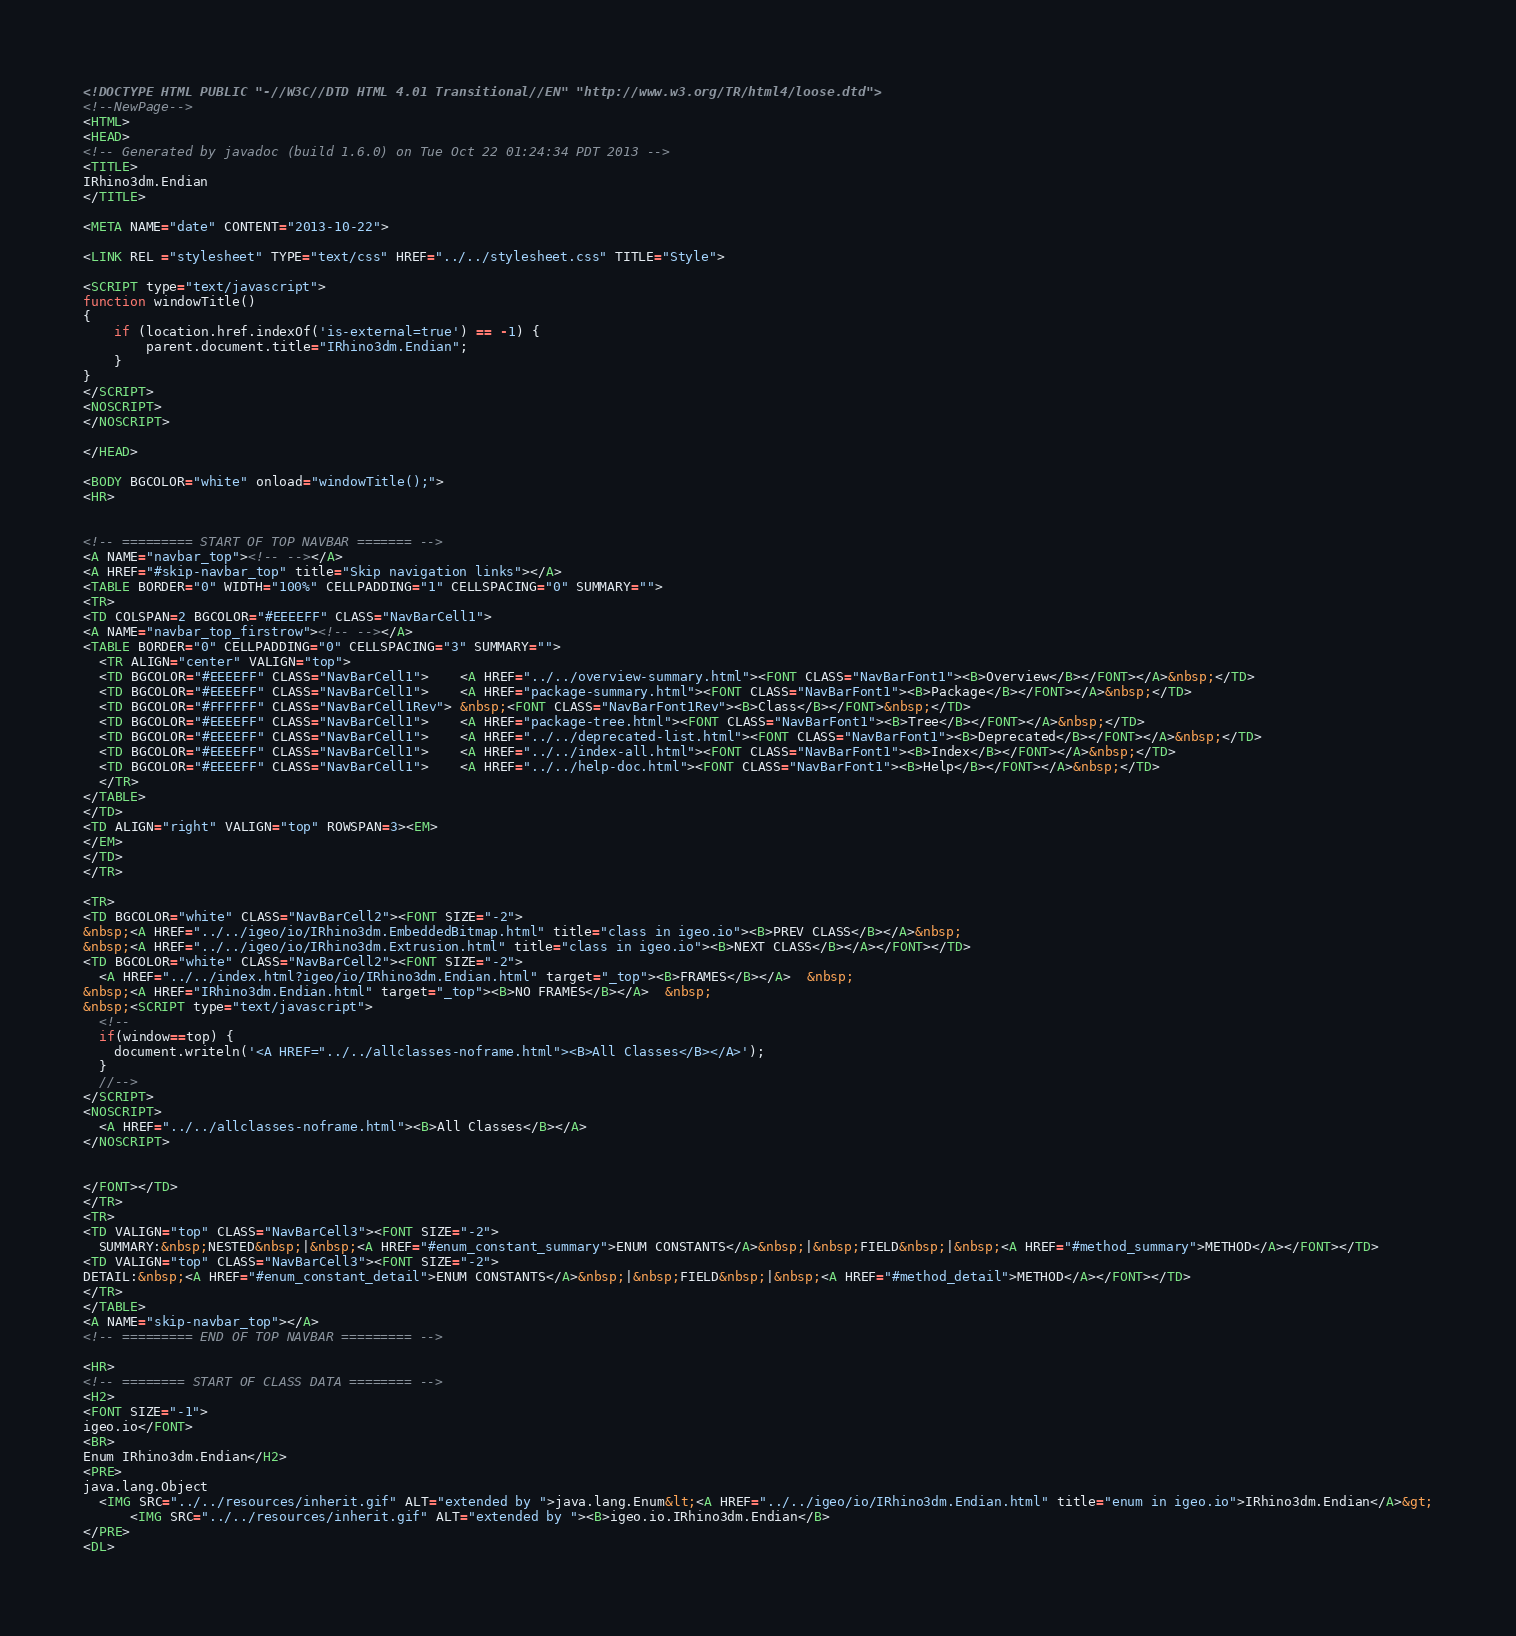<code> <loc_0><loc_0><loc_500><loc_500><_HTML_><!DOCTYPE HTML PUBLIC "-//W3C//DTD HTML 4.01 Transitional//EN" "http://www.w3.org/TR/html4/loose.dtd">
<!--NewPage-->
<HTML>
<HEAD>
<!-- Generated by javadoc (build 1.6.0) on Tue Oct 22 01:24:34 PDT 2013 -->
<TITLE>
IRhino3dm.Endian
</TITLE>

<META NAME="date" CONTENT="2013-10-22">

<LINK REL ="stylesheet" TYPE="text/css" HREF="../../stylesheet.css" TITLE="Style">

<SCRIPT type="text/javascript">
function windowTitle()
{
    if (location.href.indexOf('is-external=true') == -1) {
        parent.document.title="IRhino3dm.Endian";
    }
}
</SCRIPT>
<NOSCRIPT>
</NOSCRIPT>

</HEAD>

<BODY BGCOLOR="white" onload="windowTitle();">
<HR>


<!-- ========= START OF TOP NAVBAR ======= -->
<A NAME="navbar_top"><!-- --></A>
<A HREF="#skip-navbar_top" title="Skip navigation links"></A>
<TABLE BORDER="0" WIDTH="100%" CELLPADDING="1" CELLSPACING="0" SUMMARY="">
<TR>
<TD COLSPAN=2 BGCOLOR="#EEEEFF" CLASS="NavBarCell1">
<A NAME="navbar_top_firstrow"><!-- --></A>
<TABLE BORDER="0" CELLPADDING="0" CELLSPACING="3" SUMMARY="">
  <TR ALIGN="center" VALIGN="top">
  <TD BGCOLOR="#EEEEFF" CLASS="NavBarCell1">    <A HREF="../../overview-summary.html"><FONT CLASS="NavBarFont1"><B>Overview</B></FONT></A>&nbsp;</TD>
  <TD BGCOLOR="#EEEEFF" CLASS="NavBarCell1">    <A HREF="package-summary.html"><FONT CLASS="NavBarFont1"><B>Package</B></FONT></A>&nbsp;</TD>
  <TD BGCOLOR="#FFFFFF" CLASS="NavBarCell1Rev"> &nbsp;<FONT CLASS="NavBarFont1Rev"><B>Class</B></FONT>&nbsp;</TD>
  <TD BGCOLOR="#EEEEFF" CLASS="NavBarCell1">    <A HREF="package-tree.html"><FONT CLASS="NavBarFont1"><B>Tree</B></FONT></A>&nbsp;</TD>
  <TD BGCOLOR="#EEEEFF" CLASS="NavBarCell1">    <A HREF="../../deprecated-list.html"><FONT CLASS="NavBarFont1"><B>Deprecated</B></FONT></A>&nbsp;</TD>
  <TD BGCOLOR="#EEEEFF" CLASS="NavBarCell1">    <A HREF="../../index-all.html"><FONT CLASS="NavBarFont1"><B>Index</B></FONT></A>&nbsp;</TD>
  <TD BGCOLOR="#EEEEFF" CLASS="NavBarCell1">    <A HREF="../../help-doc.html"><FONT CLASS="NavBarFont1"><B>Help</B></FONT></A>&nbsp;</TD>
  </TR>
</TABLE>
</TD>
<TD ALIGN="right" VALIGN="top" ROWSPAN=3><EM>
</EM>
</TD>
</TR>

<TR>
<TD BGCOLOR="white" CLASS="NavBarCell2"><FONT SIZE="-2">
&nbsp;<A HREF="../../igeo/io/IRhino3dm.EmbeddedBitmap.html" title="class in igeo.io"><B>PREV CLASS</B></A>&nbsp;
&nbsp;<A HREF="../../igeo/io/IRhino3dm.Extrusion.html" title="class in igeo.io"><B>NEXT CLASS</B></A></FONT></TD>
<TD BGCOLOR="white" CLASS="NavBarCell2"><FONT SIZE="-2">
  <A HREF="../../index.html?igeo/io/IRhino3dm.Endian.html" target="_top"><B>FRAMES</B></A>  &nbsp;
&nbsp;<A HREF="IRhino3dm.Endian.html" target="_top"><B>NO FRAMES</B></A>  &nbsp;
&nbsp;<SCRIPT type="text/javascript">
  <!--
  if(window==top) {
    document.writeln('<A HREF="../../allclasses-noframe.html"><B>All Classes</B></A>');
  }
  //-->
</SCRIPT>
<NOSCRIPT>
  <A HREF="../../allclasses-noframe.html"><B>All Classes</B></A>
</NOSCRIPT>


</FONT></TD>
</TR>
<TR>
<TD VALIGN="top" CLASS="NavBarCell3"><FONT SIZE="-2">
  SUMMARY:&nbsp;NESTED&nbsp;|&nbsp;<A HREF="#enum_constant_summary">ENUM CONSTANTS</A>&nbsp;|&nbsp;FIELD&nbsp;|&nbsp;<A HREF="#method_summary">METHOD</A></FONT></TD>
<TD VALIGN="top" CLASS="NavBarCell3"><FONT SIZE="-2">
DETAIL:&nbsp;<A HREF="#enum_constant_detail">ENUM CONSTANTS</A>&nbsp;|&nbsp;FIELD&nbsp;|&nbsp;<A HREF="#method_detail">METHOD</A></FONT></TD>
</TR>
</TABLE>
<A NAME="skip-navbar_top"></A>
<!-- ========= END OF TOP NAVBAR ========= -->

<HR>
<!-- ======== START OF CLASS DATA ======== -->
<H2>
<FONT SIZE="-1">
igeo.io</FONT>
<BR>
Enum IRhino3dm.Endian</H2>
<PRE>
java.lang.Object
  <IMG SRC="../../resources/inherit.gif" ALT="extended by ">java.lang.Enum&lt;<A HREF="../../igeo/io/IRhino3dm.Endian.html" title="enum in igeo.io">IRhino3dm.Endian</A>&gt;
      <IMG SRC="../../resources/inherit.gif" ALT="extended by "><B>igeo.io.IRhino3dm.Endian</B>
</PRE>
<DL></code> 